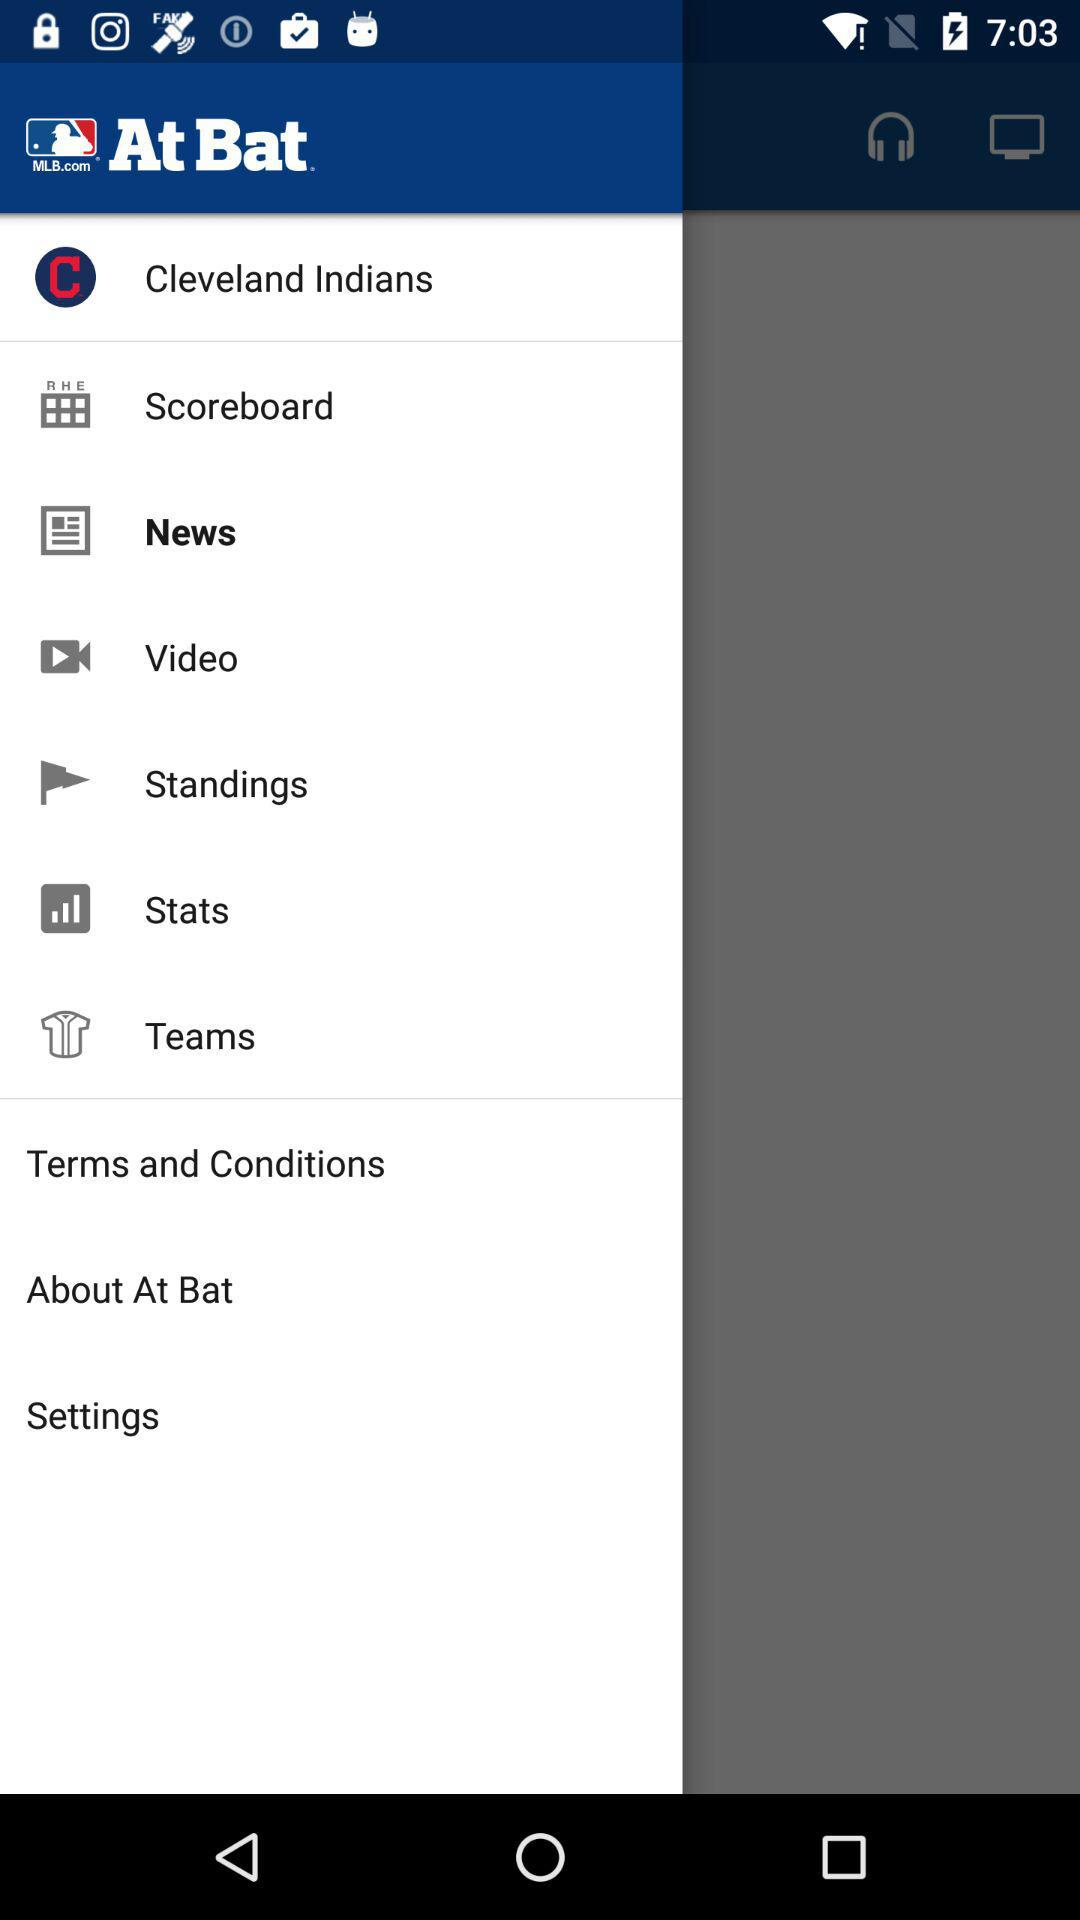What is the selected item? The item "News" is selected. 